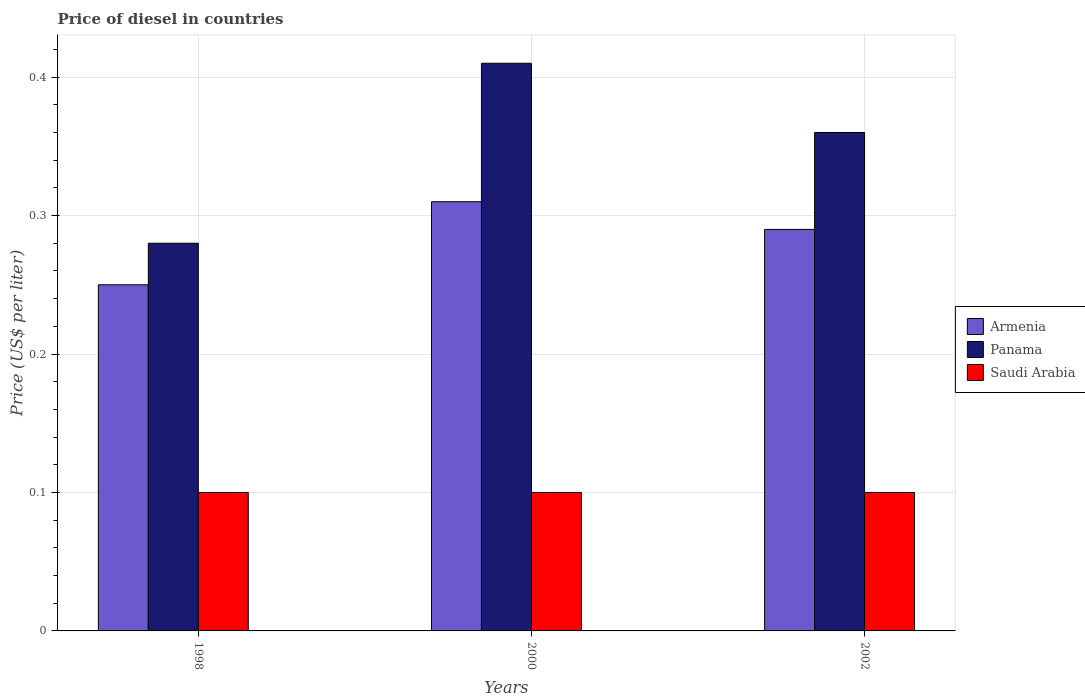How many different coloured bars are there?
Provide a succinct answer. 3. How many groups of bars are there?
Your answer should be compact. 3. Are the number of bars per tick equal to the number of legend labels?
Provide a succinct answer. Yes. How many bars are there on the 2nd tick from the left?
Ensure brevity in your answer.  3. What is the label of the 3rd group of bars from the left?
Ensure brevity in your answer.  2002. What is the price of diesel in Panama in 2000?
Offer a terse response. 0.41. Across all years, what is the maximum price of diesel in Armenia?
Your response must be concise. 0.31. Across all years, what is the minimum price of diesel in Panama?
Your response must be concise. 0.28. What is the total price of diesel in Panama in the graph?
Make the answer very short. 1.05. What is the difference between the price of diesel in Panama in 1998 and the price of diesel in Armenia in 2002?
Offer a terse response. -0.01. What is the average price of diesel in Saudi Arabia per year?
Make the answer very short. 0.1. In the year 2002, what is the difference between the price of diesel in Saudi Arabia and price of diesel in Panama?
Your answer should be very brief. -0.26. In how many years, is the price of diesel in Saudi Arabia greater than 0.28 US$?
Provide a short and direct response. 0. What is the ratio of the price of diesel in Panama in 1998 to that in 2002?
Make the answer very short. 0.78. Is the price of diesel in Panama in 1998 less than that in 2002?
Give a very brief answer. Yes. Is the difference between the price of diesel in Saudi Arabia in 2000 and 2002 greater than the difference between the price of diesel in Panama in 2000 and 2002?
Provide a succinct answer. No. What is the difference between the highest and the lowest price of diesel in Saudi Arabia?
Your response must be concise. 0. In how many years, is the price of diesel in Saudi Arabia greater than the average price of diesel in Saudi Arabia taken over all years?
Your answer should be compact. 0. Is the sum of the price of diesel in Saudi Arabia in 1998 and 2002 greater than the maximum price of diesel in Armenia across all years?
Offer a very short reply. No. What does the 2nd bar from the left in 2000 represents?
Make the answer very short. Panama. What does the 3rd bar from the right in 1998 represents?
Your answer should be compact. Armenia. Is it the case that in every year, the sum of the price of diesel in Panama and price of diesel in Saudi Arabia is greater than the price of diesel in Armenia?
Offer a terse response. Yes. How many bars are there?
Your response must be concise. 9. Are all the bars in the graph horizontal?
Make the answer very short. No. How many years are there in the graph?
Make the answer very short. 3. Does the graph contain any zero values?
Give a very brief answer. No. Does the graph contain grids?
Offer a terse response. Yes. How many legend labels are there?
Your answer should be very brief. 3. How are the legend labels stacked?
Keep it short and to the point. Vertical. What is the title of the graph?
Provide a succinct answer. Price of diesel in countries. Does "Israel" appear as one of the legend labels in the graph?
Provide a short and direct response. No. What is the label or title of the Y-axis?
Ensure brevity in your answer.  Price (US$ per liter). What is the Price (US$ per liter) of Armenia in 1998?
Ensure brevity in your answer.  0.25. What is the Price (US$ per liter) in Panama in 1998?
Your response must be concise. 0.28. What is the Price (US$ per liter) in Armenia in 2000?
Provide a short and direct response. 0.31. What is the Price (US$ per liter) of Panama in 2000?
Offer a very short reply. 0.41. What is the Price (US$ per liter) of Saudi Arabia in 2000?
Give a very brief answer. 0.1. What is the Price (US$ per liter) of Armenia in 2002?
Keep it short and to the point. 0.29. What is the Price (US$ per liter) in Panama in 2002?
Give a very brief answer. 0.36. What is the Price (US$ per liter) of Saudi Arabia in 2002?
Give a very brief answer. 0.1. Across all years, what is the maximum Price (US$ per liter) of Armenia?
Provide a short and direct response. 0.31. Across all years, what is the maximum Price (US$ per liter) in Panama?
Your answer should be very brief. 0.41. Across all years, what is the maximum Price (US$ per liter) of Saudi Arabia?
Provide a succinct answer. 0.1. Across all years, what is the minimum Price (US$ per liter) in Armenia?
Make the answer very short. 0.25. Across all years, what is the minimum Price (US$ per liter) of Panama?
Give a very brief answer. 0.28. What is the total Price (US$ per liter) in Armenia in the graph?
Provide a short and direct response. 0.85. What is the difference between the Price (US$ per liter) of Armenia in 1998 and that in 2000?
Your answer should be very brief. -0.06. What is the difference between the Price (US$ per liter) of Panama in 1998 and that in 2000?
Give a very brief answer. -0.13. What is the difference between the Price (US$ per liter) in Armenia in 1998 and that in 2002?
Provide a succinct answer. -0.04. What is the difference between the Price (US$ per liter) in Panama in 1998 and that in 2002?
Provide a short and direct response. -0.08. What is the difference between the Price (US$ per liter) of Armenia in 2000 and that in 2002?
Offer a very short reply. 0.02. What is the difference between the Price (US$ per liter) of Panama in 2000 and that in 2002?
Your response must be concise. 0.05. What is the difference between the Price (US$ per liter) of Saudi Arabia in 2000 and that in 2002?
Make the answer very short. 0. What is the difference between the Price (US$ per liter) in Armenia in 1998 and the Price (US$ per liter) in Panama in 2000?
Provide a succinct answer. -0.16. What is the difference between the Price (US$ per liter) in Armenia in 1998 and the Price (US$ per liter) in Saudi Arabia in 2000?
Offer a very short reply. 0.15. What is the difference between the Price (US$ per liter) in Panama in 1998 and the Price (US$ per liter) in Saudi Arabia in 2000?
Provide a succinct answer. 0.18. What is the difference between the Price (US$ per liter) in Armenia in 1998 and the Price (US$ per liter) in Panama in 2002?
Ensure brevity in your answer.  -0.11. What is the difference between the Price (US$ per liter) in Panama in 1998 and the Price (US$ per liter) in Saudi Arabia in 2002?
Your answer should be very brief. 0.18. What is the difference between the Price (US$ per liter) in Armenia in 2000 and the Price (US$ per liter) in Panama in 2002?
Provide a succinct answer. -0.05. What is the difference between the Price (US$ per liter) of Armenia in 2000 and the Price (US$ per liter) of Saudi Arabia in 2002?
Your answer should be compact. 0.21. What is the difference between the Price (US$ per liter) in Panama in 2000 and the Price (US$ per liter) in Saudi Arabia in 2002?
Give a very brief answer. 0.31. What is the average Price (US$ per liter) in Armenia per year?
Give a very brief answer. 0.28. In the year 1998, what is the difference between the Price (US$ per liter) in Armenia and Price (US$ per liter) in Panama?
Provide a succinct answer. -0.03. In the year 1998, what is the difference between the Price (US$ per liter) of Armenia and Price (US$ per liter) of Saudi Arabia?
Give a very brief answer. 0.15. In the year 1998, what is the difference between the Price (US$ per liter) in Panama and Price (US$ per liter) in Saudi Arabia?
Provide a short and direct response. 0.18. In the year 2000, what is the difference between the Price (US$ per liter) of Armenia and Price (US$ per liter) of Saudi Arabia?
Ensure brevity in your answer.  0.21. In the year 2000, what is the difference between the Price (US$ per liter) of Panama and Price (US$ per liter) of Saudi Arabia?
Keep it short and to the point. 0.31. In the year 2002, what is the difference between the Price (US$ per liter) of Armenia and Price (US$ per liter) of Panama?
Your answer should be compact. -0.07. In the year 2002, what is the difference between the Price (US$ per liter) in Armenia and Price (US$ per liter) in Saudi Arabia?
Give a very brief answer. 0.19. In the year 2002, what is the difference between the Price (US$ per liter) in Panama and Price (US$ per liter) in Saudi Arabia?
Provide a short and direct response. 0.26. What is the ratio of the Price (US$ per liter) of Armenia in 1998 to that in 2000?
Offer a very short reply. 0.81. What is the ratio of the Price (US$ per liter) of Panama in 1998 to that in 2000?
Your response must be concise. 0.68. What is the ratio of the Price (US$ per liter) in Armenia in 1998 to that in 2002?
Your answer should be very brief. 0.86. What is the ratio of the Price (US$ per liter) of Saudi Arabia in 1998 to that in 2002?
Your answer should be very brief. 1. What is the ratio of the Price (US$ per liter) of Armenia in 2000 to that in 2002?
Offer a very short reply. 1.07. What is the ratio of the Price (US$ per liter) of Panama in 2000 to that in 2002?
Offer a terse response. 1.14. What is the ratio of the Price (US$ per liter) in Saudi Arabia in 2000 to that in 2002?
Keep it short and to the point. 1. What is the difference between the highest and the second highest Price (US$ per liter) of Armenia?
Ensure brevity in your answer.  0.02. What is the difference between the highest and the second highest Price (US$ per liter) in Panama?
Offer a very short reply. 0.05. What is the difference between the highest and the second highest Price (US$ per liter) in Saudi Arabia?
Give a very brief answer. 0. What is the difference between the highest and the lowest Price (US$ per liter) in Armenia?
Your response must be concise. 0.06. What is the difference between the highest and the lowest Price (US$ per liter) of Panama?
Your answer should be very brief. 0.13. What is the difference between the highest and the lowest Price (US$ per liter) in Saudi Arabia?
Keep it short and to the point. 0. 